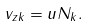<formula> <loc_0><loc_0><loc_500><loc_500>v _ { z k } = u N _ { k } .</formula> 